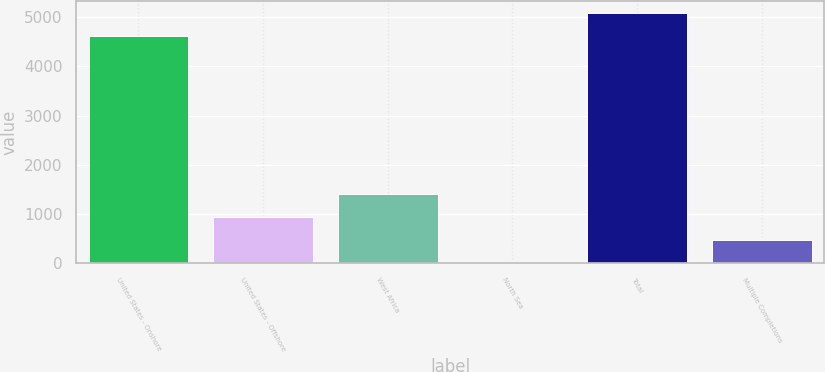<chart> <loc_0><loc_0><loc_500><loc_500><bar_chart><fcel>United States - Onshore<fcel>United States - Offshore<fcel>West Africa<fcel>North Sea<fcel>Total<fcel>Multiple Completions<nl><fcel>4609<fcel>938.2<fcel>1403.8<fcel>7<fcel>5074.6<fcel>472.6<nl></chart> 